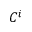Convert formula to latex. <formula><loc_0><loc_0><loc_500><loc_500>C ^ { i }</formula> 